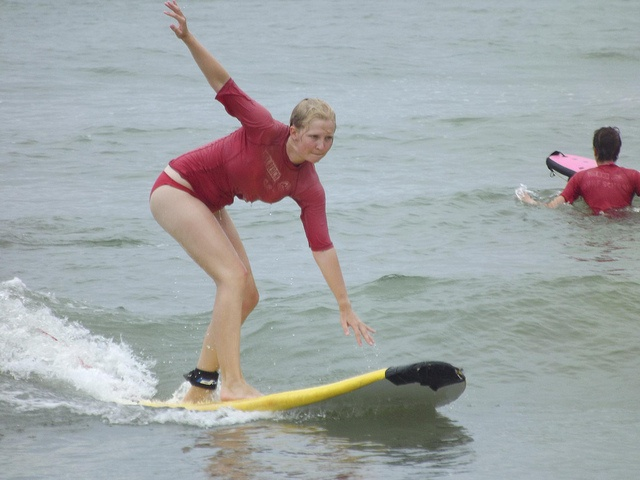Describe the objects in this image and their specific colors. I can see people in darkgray, brown, and tan tones, surfboard in darkgray, gray, black, and khaki tones, people in darkgray, brown, maroon, and black tones, and surfboard in darkgray, pink, gray, and black tones in this image. 